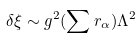<formula> <loc_0><loc_0><loc_500><loc_500>\delta \xi \sim g ^ { 2 } ( \sum r _ { \alpha } ) \Lambda ^ { 2 }</formula> 